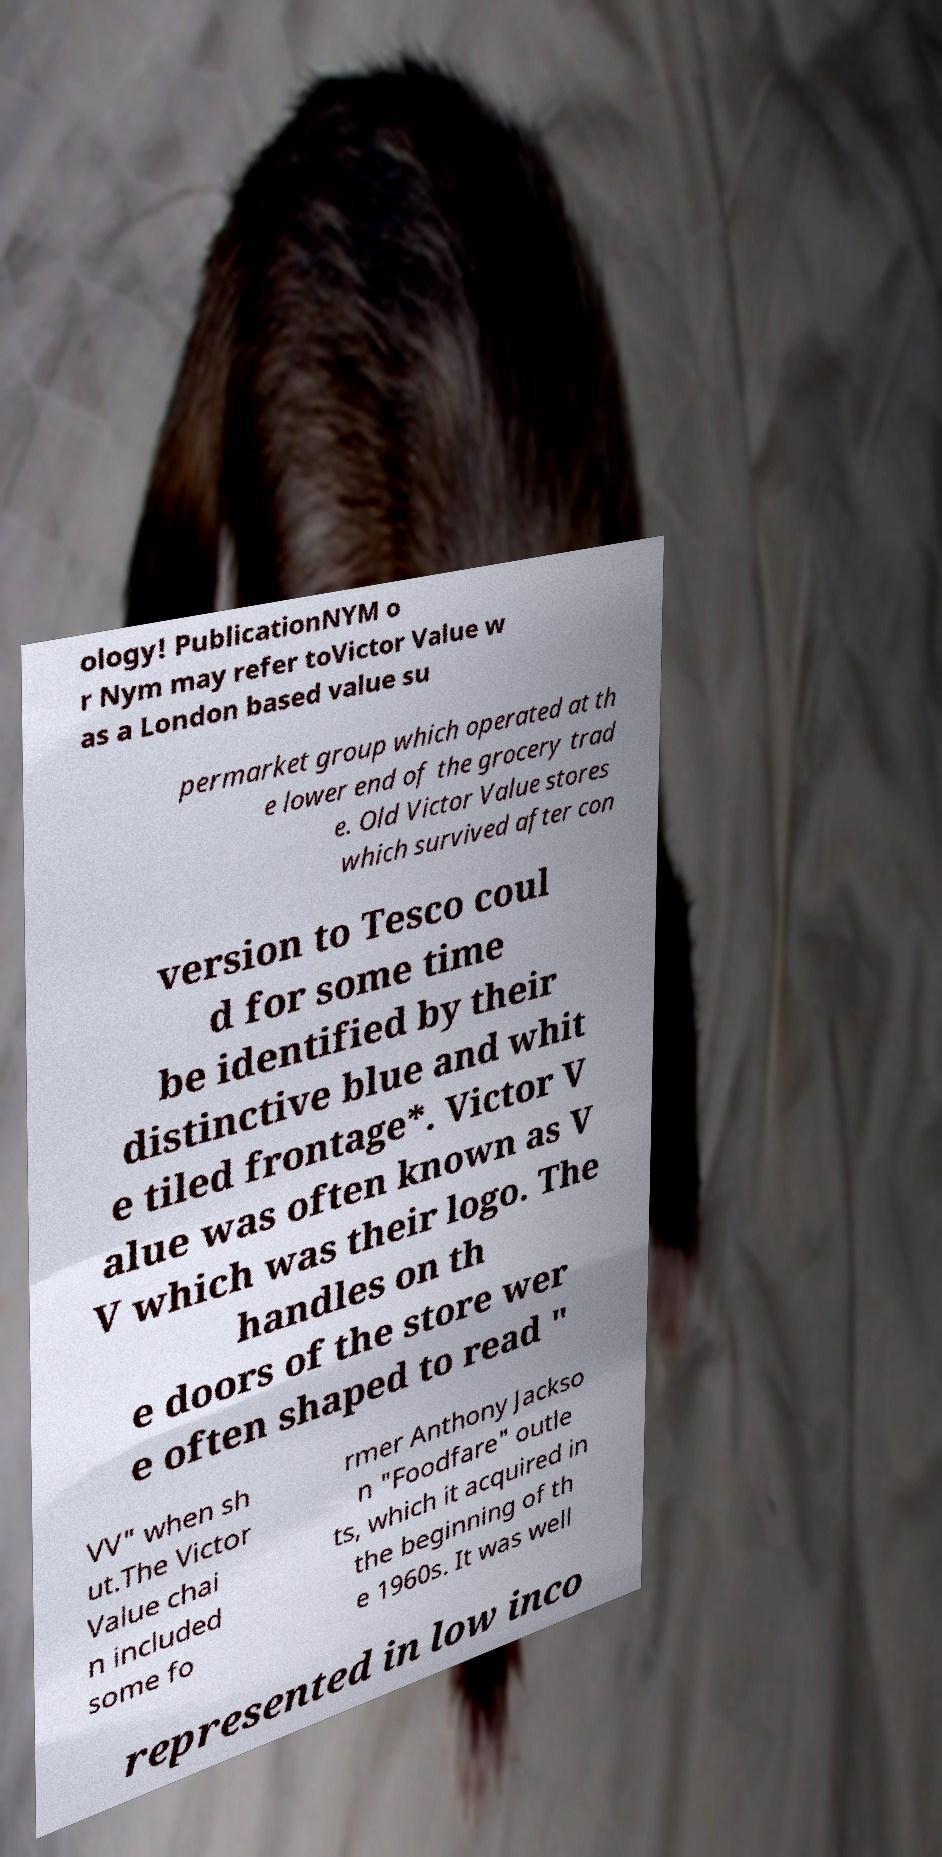Can you read and provide the text displayed in the image?This photo seems to have some interesting text. Can you extract and type it out for me? ology! PublicationNYM o r Nym may refer toVictor Value w as a London based value su permarket group which operated at th e lower end of the grocery trad e. Old Victor Value stores which survived after con version to Tesco coul d for some time be identified by their distinctive blue and whit e tiled frontage*. Victor V alue was often known as V V which was their logo. The handles on th e doors of the store wer e often shaped to read " VV" when sh ut.The Victor Value chai n included some fo rmer Anthony Jackso n "Foodfare" outle ts, which it acquired in the beginning of th e 1960s. It was well represented in low inco 